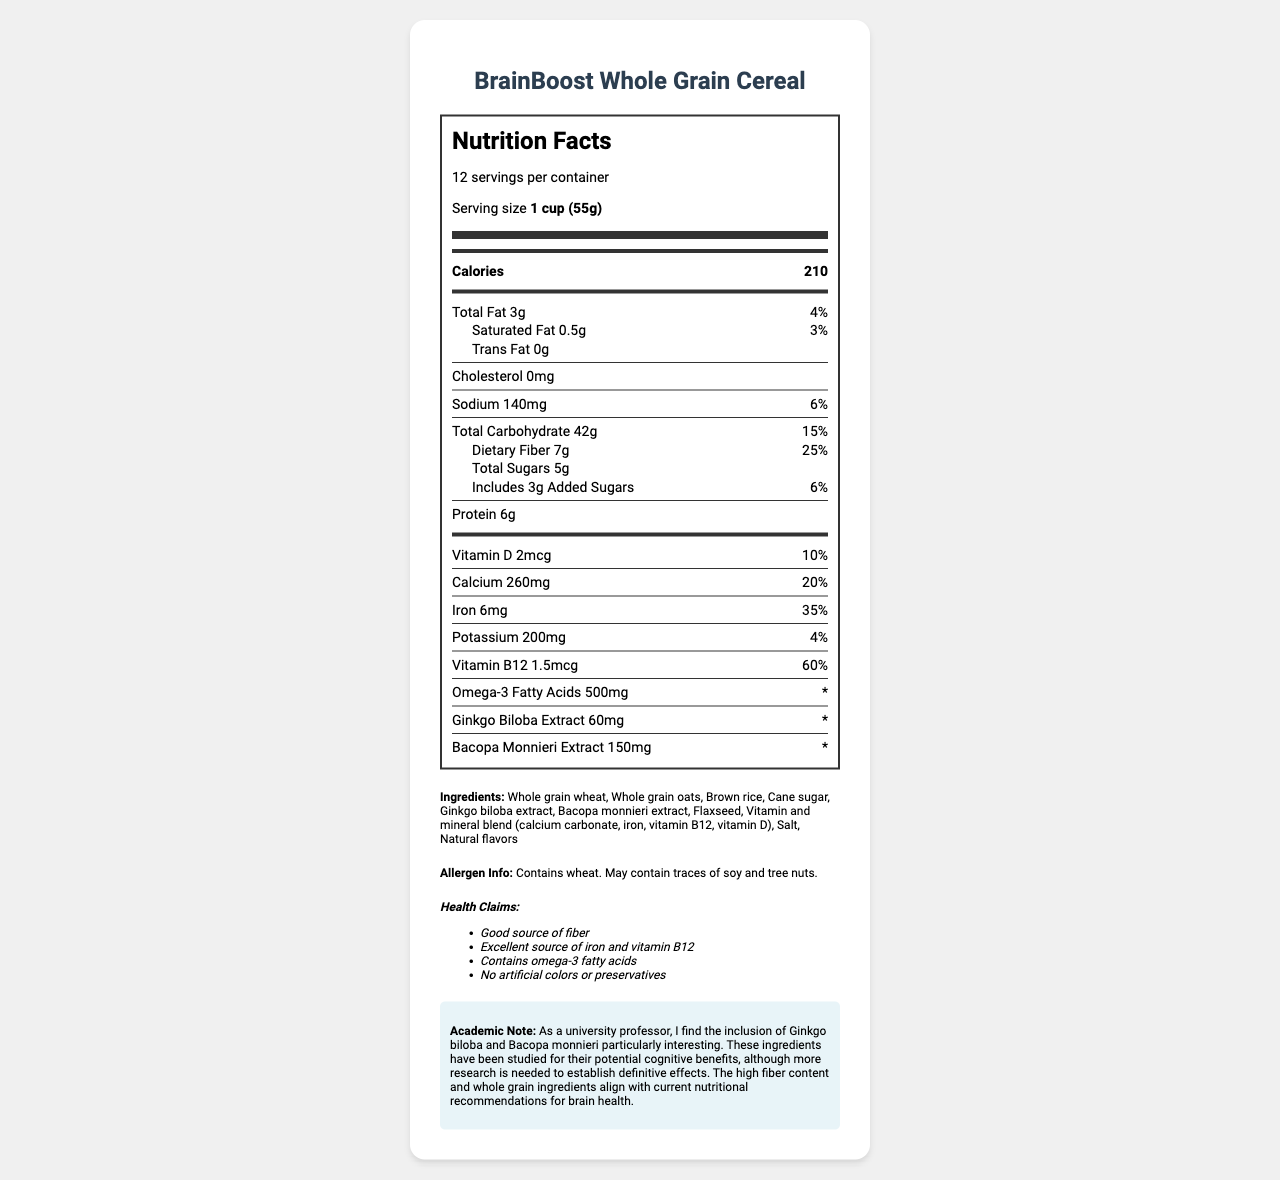What is the serving size of BrainBoost Whole Grain Cereal? The serving size is mentioned at the top of the Nutrition Facts section, indicating it is 1 cup (55g).
Answer: 1 cup (55g) How many calories are in one serving? The calories per serving are clearly listed as 210.
Answer: 210 What is the total dietary fiber in one serving? The Nutrition Facts state that the total dietary fiber per serving is 7 grams.
Answer: 7g How much protein does each serving contain? Each serving of the cereal contains 6 grams of protein.
Answer: 6g What is the daily value percentage for iron in one serving? Under the Iron section in the Nutrition Facts, it indicates that the daily value for iron is 35%.
Answer: 35% Which of the following ingredients are found in the cereal? A. Almonds B. Brown rice C. Honey D. Corn The list of ingredients includes brown rice, but not almonds, honey, or corn.
Answer: B What amount of Vitamin B12 is in one serving? 
A. 1.5mcg 
B. 2mcg 
C. 1mcg 
D. 3mcg The Vitamin B12 amount per serving is listed as 1.5mcg.
Answer: A Does the cereal contain any artificial colors or preservatives? One of the health claims states that the cereal contains no artificial colors or preservatives.
Answer: No Is Ginkgo biloba extract included in the ingredients? Ginkgo biloba extract is listed as one of the ingredients in the cereal.
Answer: Yes Can we determine the exact effects of Ginkgo biloba and Bacopa monnieri on cognitive function from the document? The academic note mentions that while these ingredients have been studied for potential cognitive benefits, more research is needed to establish definitive effects.
Answer: No Summarize the main idea of the document. The document presents comprehensive nutritional information about BrainBoost Whole Grain Cereal, highlighting its content and potential cognitive benefits. It focuses on the ingredients, nutrition value, health claims, and academic insights, giving a thorough overview of the product's attributes.
Answer: BrainBoost Whole Grain Cereal is a nutritionally rich product marketed to improve cognitive function and memory, featuring ingredients like whole grains, fiber, and specific extracts like Ginkgo biloba and Bacopa monnieri. It provides detailed nutrition facts and health claims, emphasizing its benefits and lack of artificial additives. 